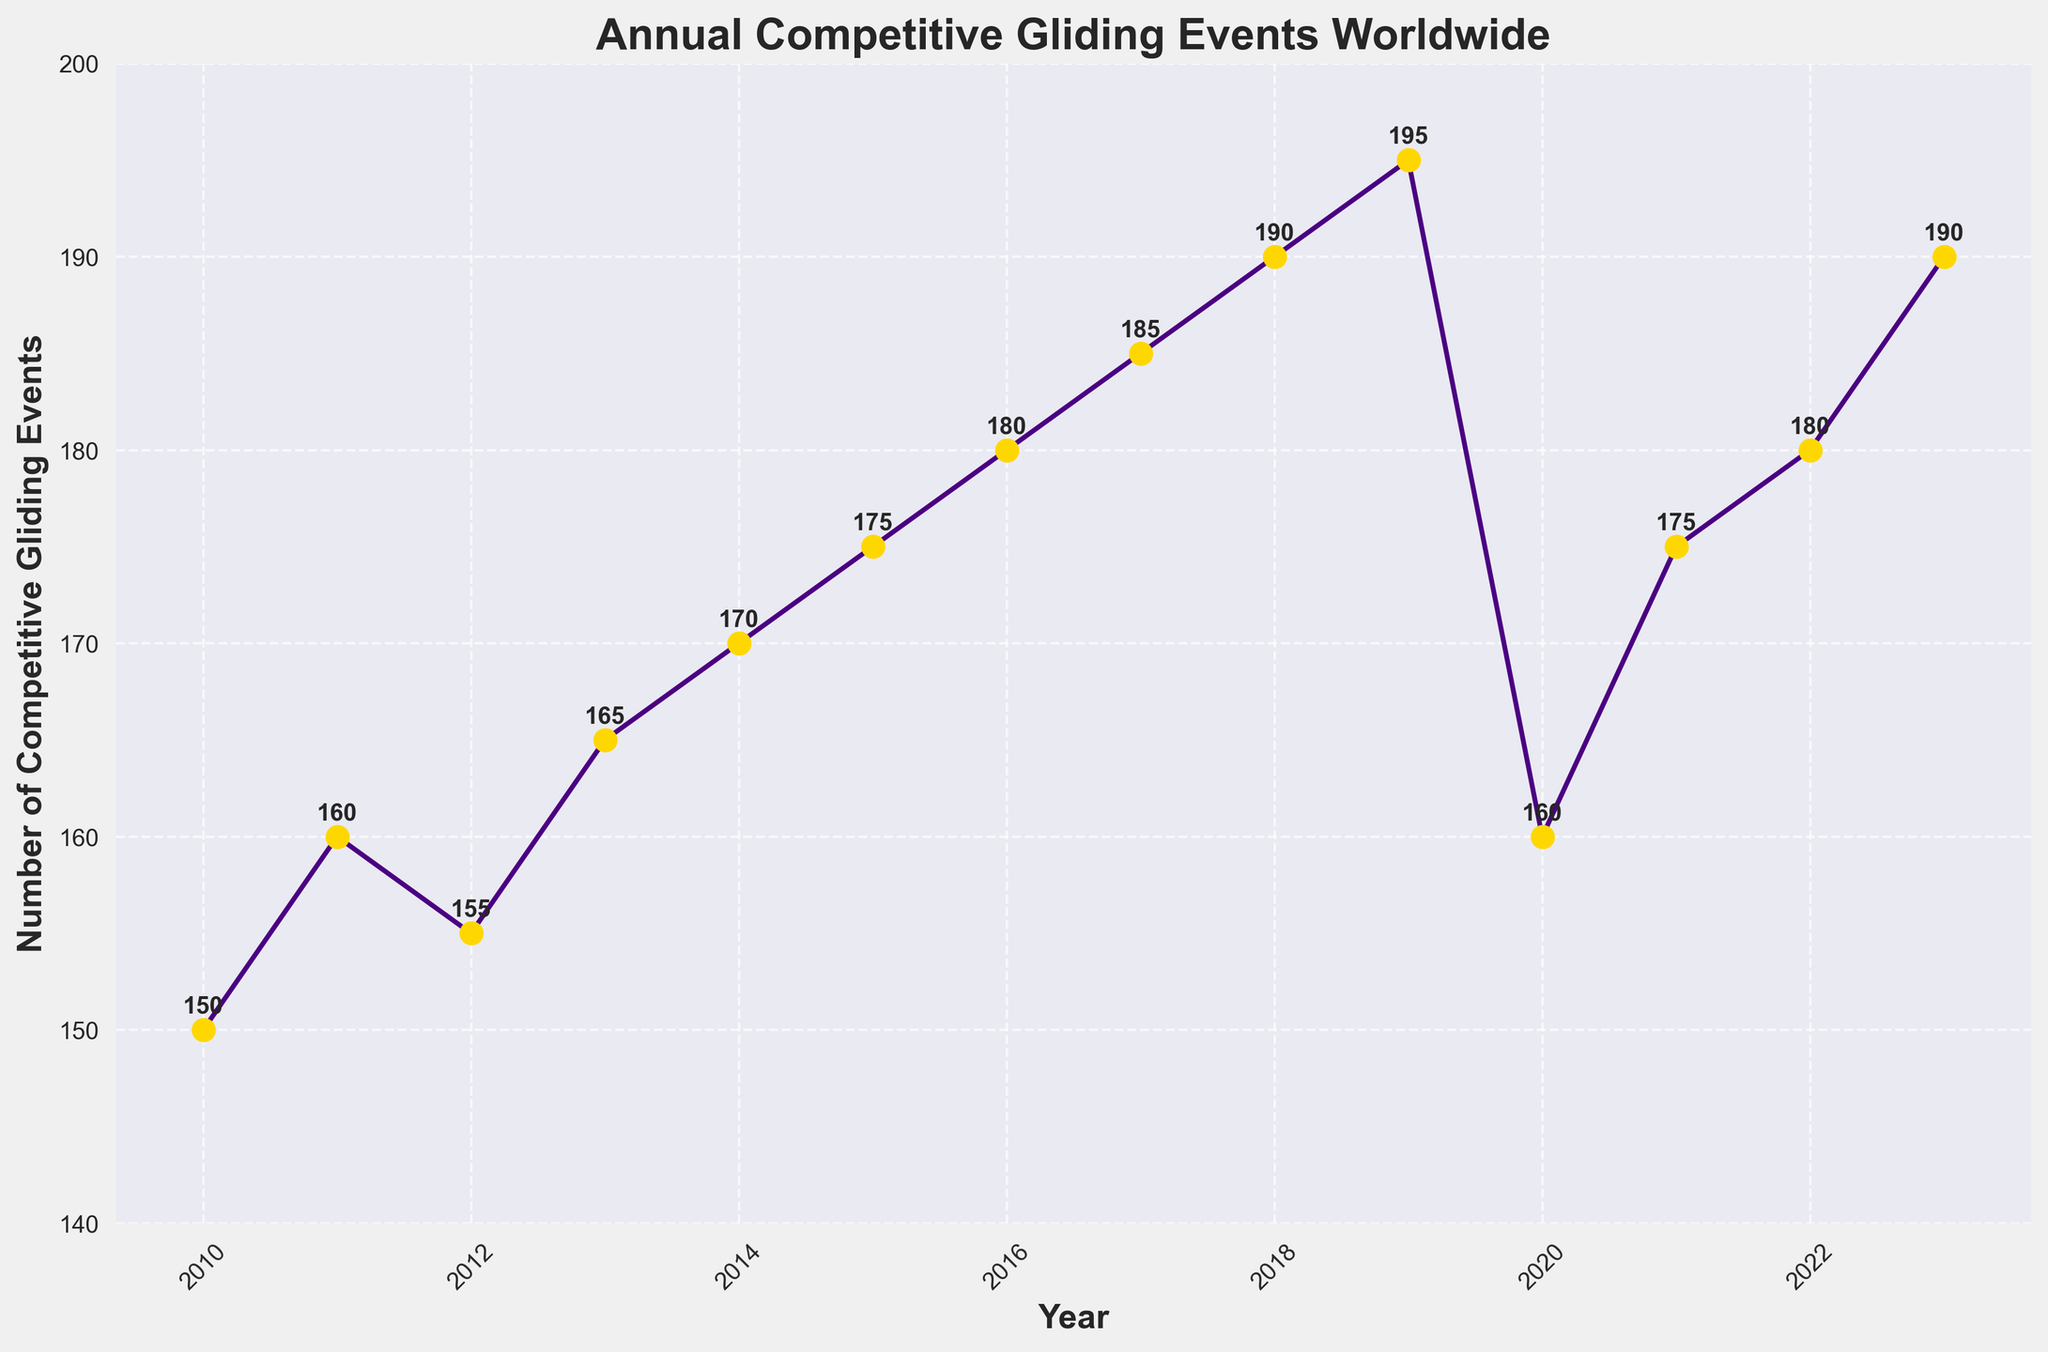What is the title of the figure? The title is placed at the top of the figure. It reads as "Annual Competitive Gliding Events Worldwide."
Answer: Annual Competitive Gliding Events Worldwide What is the range of years covered in the figure? The x-axis of the figure represents the years, which range from 2010 to 2023.
Answer: 2010 to 2023 How many competitive gliding events were held in 2020? To find the number of events in 2020, look at the data point for the year 2020 on the x-axis. It is annotated with the value 160.
Answer: 160 What is the overall trend in the number of competitive gliding events from 2010 to 2023? The number of competitive gliding events generally increases from 2010 to 2023 with a noticeable drop in 2020, likely due to external factors like the COVID-19 pandemic.
Answer: Increasing trend with a dip in 2020 Which year had the highest number of competitive gliding events? The highest point on the y-axis indicates the year with the most events. The year 2019 and 2023 had the highest number of events, both with 195 and 190 respectively.
Answer: 2019 and 2023 How does the number of events in 2020 compare with 2019 and 2021? In 2019, there were 195 events, it dropped to 160 in 2020, then rose to 175 in 2021. Thus, 2020 had significantly fewer events compared to both 2019 and 2021.
Answer: 2020 had fewer events What is the average number of competitive gliding events held annually from 2010 to 2023? Sum all the annual numbers of events and divide by the number of years (14). The total number of events is 2400, so the average is 2400 ÷ 14 = 171.43.
Answer: 171.43 How significant was the drop in the number of events from 2019 to 2020? Calculate the difference in the number of events between 2019 (195 events) and 2020 (160 events). The drop is 195 - 160 = 35 events.
Answer: 35 events What was the annual growth in the number of events from 2011 to 2013? Find the numbers for 2011 (160), 2012 (155), and 2013 (165). Calculate the year-to-year change: (155 - 160) = -5 and (165 - 155) = 10. Average growth over these years is (-5 + 10) / 2 = 2.5 events per year.
Answer: 2.5 events per year How many years saw an increase in the number of competitive gliding events compared to the previous year? Count the years where the value is higher than the previous year. These years are 2011, 2013, 2014, 2015, 2016, 2017, 2018, 2019, 2021, and 2023 (10 years in total).
Answer: 10 years 